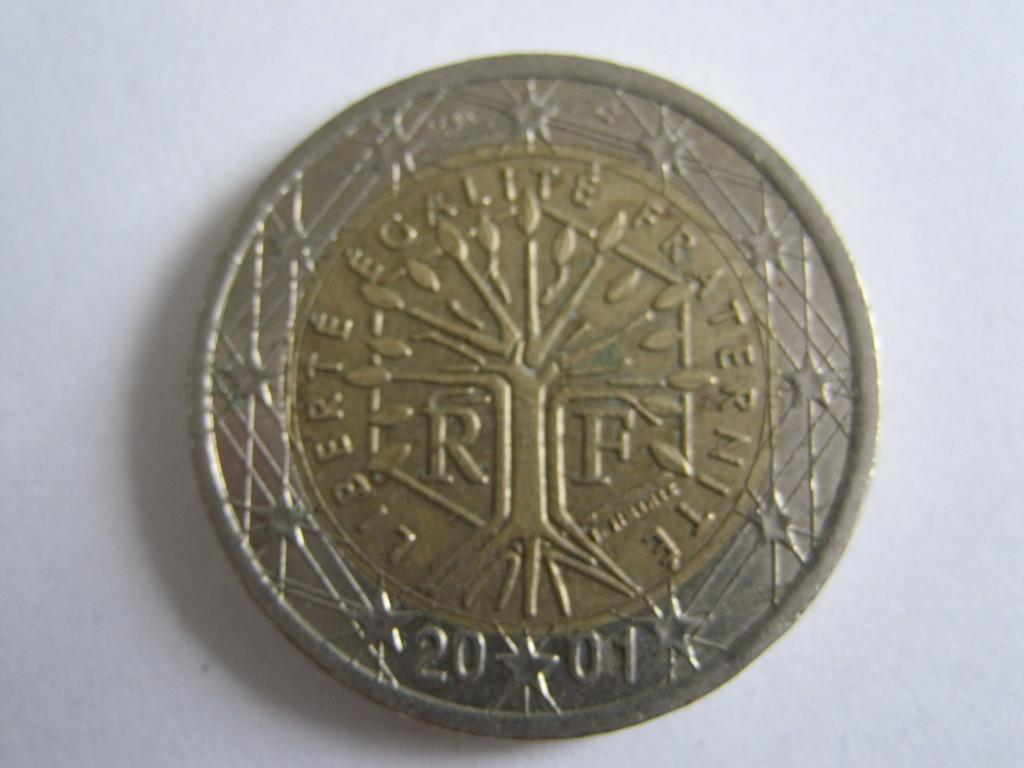Provide a one-sentence caption for the provided image. Silver and gold french coin that says liberte egalite fraternite. 